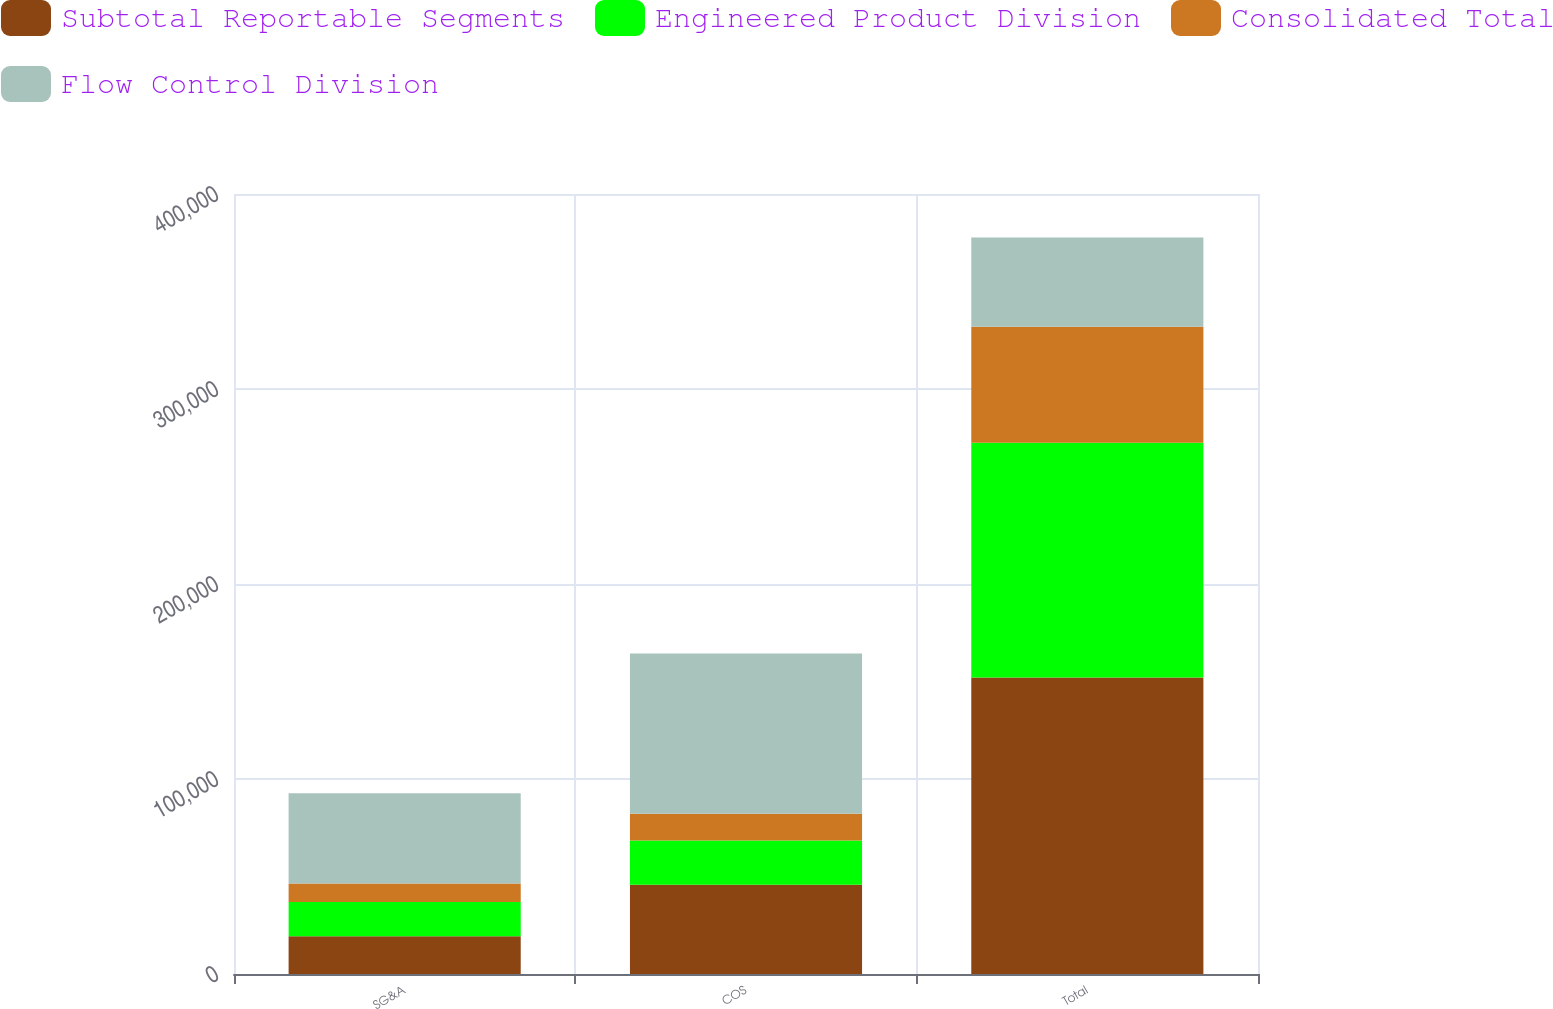Convert chart to OTSL. <chart><loc_0><loc_0><loc_500><loc_500><stacked_bar_chart><ecel><fcel>SG&A<fcel>COS<fcel>Total<nl><fcel>Subtotal Reportable Segments<fcel>19390<fcel>45731<fcel>152060<nl><fcel>Engineered Product Division<fcel>17520<fcel>22753<fcel>120380<nl><fcel>Consolidated Total<fcel>9455<fcel>13718<fcel>59510<nl><fcel>Flow Control Division<fcel>46365<fcel>82202<fcel>45731<nl></chart> 